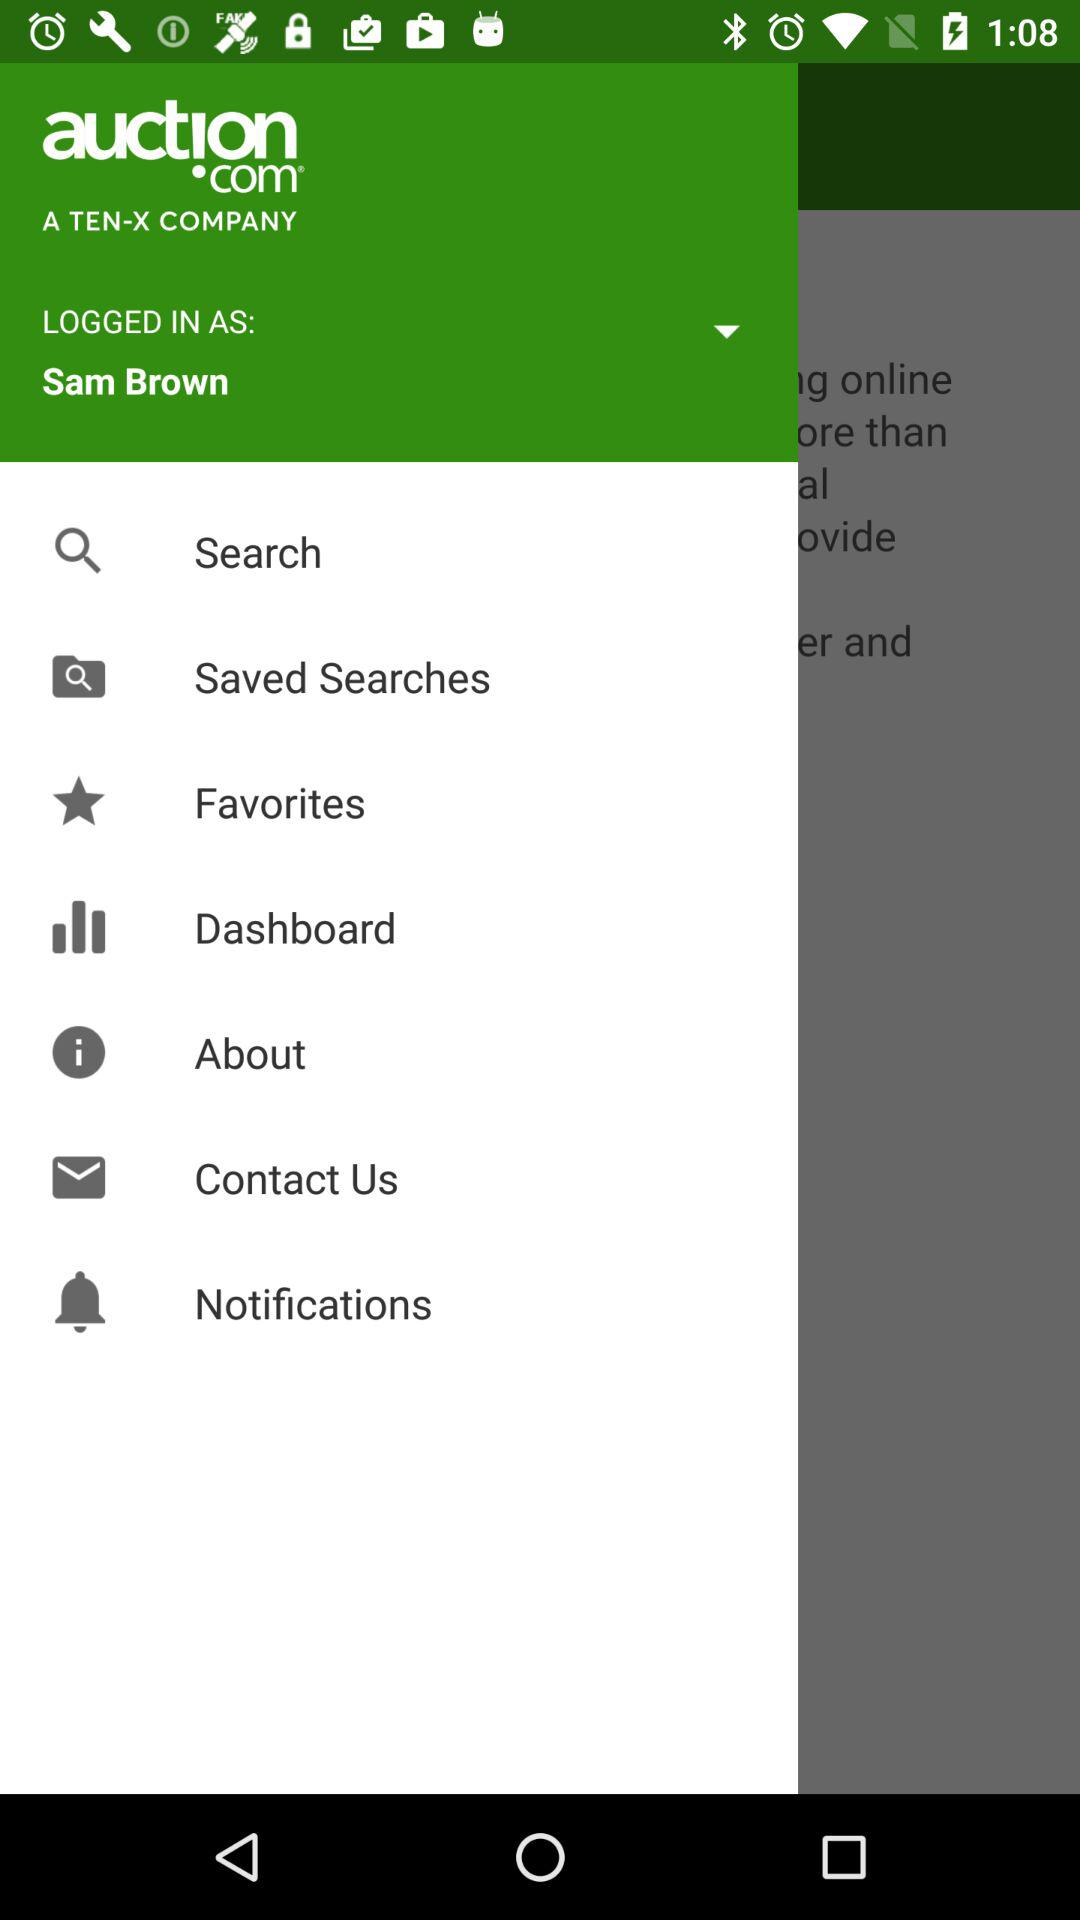What is the name of the application? The name of the application is "auctᴉon.com". 